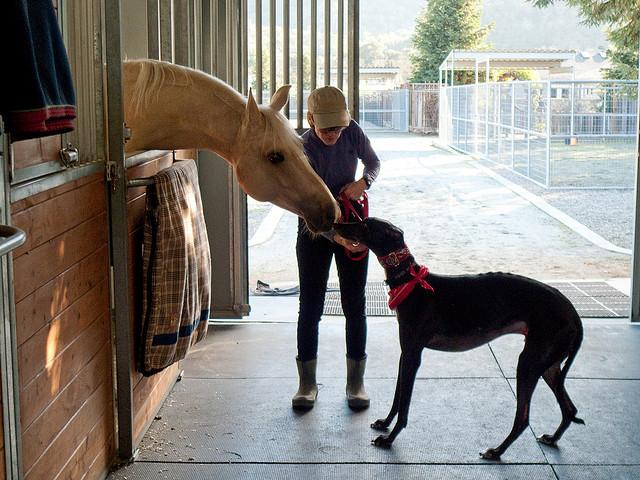What is the man wearing on his feet?
Keep it brief. Boots. What is the dog wearing?
Keep it brief. Bandana. Is the horse curious about the dog?
Keep it brief. Yes. 